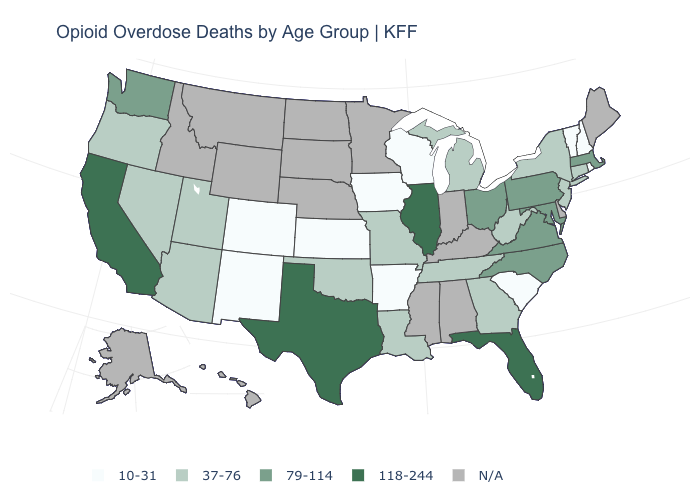Is the legend a continuous bar?
Answer briefly. No. Is the legend a continuous bar?
Short answer required. No. Is the legend a continuous bar?
Answer briefly. No. What is the highest value in the West ?
Be succinct. 118-244. Which states hav the highest value in the MidWest?
Give a very brief answer. Illinois. What is the value of Oklahoma?
Answer briefly. 37-76. What is the highest value in the USA?
Concise answer only. 118-244. Does Wisconsin have the highest value in the MidWest?
Concise answer only. No. What is the highest value in the USA?
Write a very short answer. 118-244. What is the value of Alabama?
Answer briefly. N/A. Name the states that have a value in the range 10-31?
Give a very brief answer. Arkansas, Colorado, Iowa, Kansas, New Hampshire, New Mexico, Rhode Island, South Carolina, Vermont, Wisconsin. Name the states that have a value in the range 79-114?
Give a very brief answer. Maryland, Massachusetts, North Carolina, Ohio, Pennsylvania, Virginia, Washington. Which states have the lowest value in the USA?
Concise answer only. Arkansas, Colorado, Iowa, Kansas, New Hampshire, New Mexico, Rhode Island, South Carolina, Vermont, Wisconsin. What is the value of Florida?
Answer briefly. 118-244. 